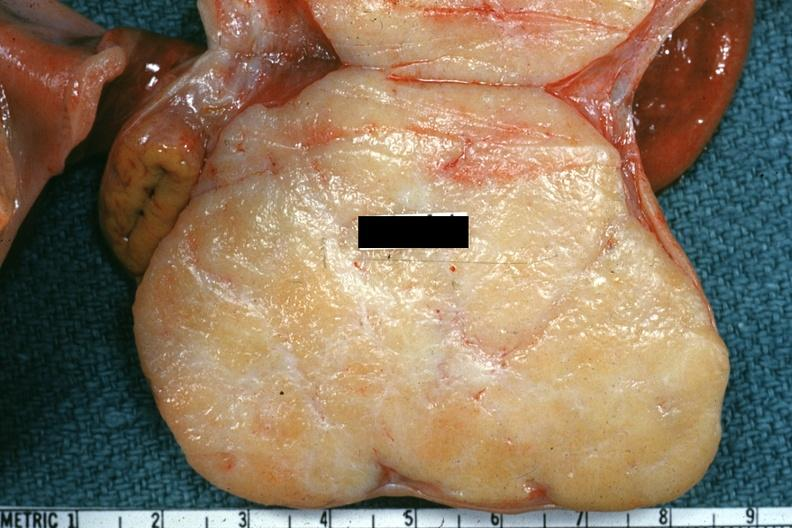s endocrine present?
Answer the question using a single word or phrase. No 